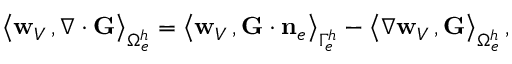Convert formula to latex. <formula><loc_0><loc_0><loc_500><loc_500>\begin{array} { r } { \left \langle { { w } _ { V } } \, , \nabla \cdot { G } \right \rangle _ { \Omega _ { e } ^ { h } } = \left \langle { { w } _ { V } } \, , { G } \cdot { n } _ { e } \right \rangle _ { \Gamma _ { e } ^ { h } } - \left \langle \nabla { { w } _ { V } } \, , { G } \right \rangle _ { \Omega _ { e } ^ { h } } \, , } \end{array}</formula> 